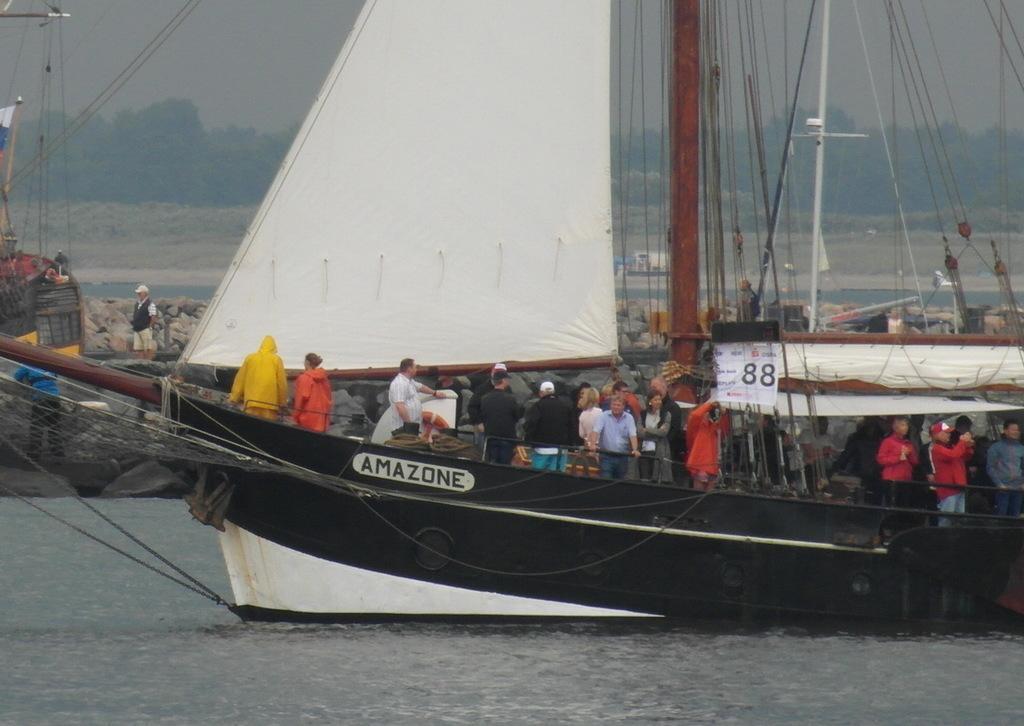Can you describe this image briefly? At the bottom of the image there is water and we can see a ship on the water. There are people in the ship. In the background there are trees and sky. On the left there are people. 